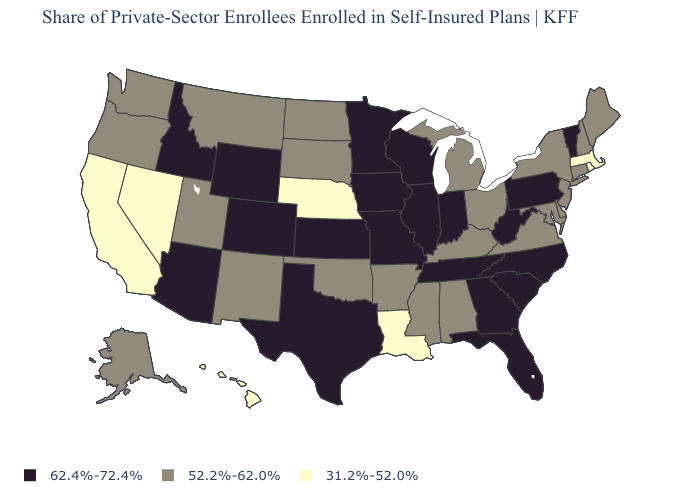What is the highest value in the USA?
Keep it brief. 62.4%-72.4%. Which states have the lowest value in the West?
Write a very short answer. California, Hawaii, Nevada. What is the highest value in states that border South Carolina?
Answer briefly. 62.4%-72.4%. What is the value of California?
Quick response, please. 31.2%-52.0%. How many symbols are there in the legend?
Quick response, please. 3. Which states have the highest value in the USA?
Concise answer only. Arizona, Colorado, Florida, Georgia, Idaho, Illinois, Indiana, Iowa, Kansas, Minnesota, Missouri, North Carolina, Pennsylvania, South Carolina, Tennessee, Texas, Vermont, West Virginia, Wisconsin, Wyoming. Which states have the highest value in the USA?
Give a very brief answer. Arizona, Colorado, Florida, Georgia, Idaho, Illinois, Indiana, Iowa, Kansas, Minnesota, Missouri, North Carolina, Pennsylvania, South Carolina, Tennessee, Texas, Vermont, West Virginia, Wisconsin, Wyoming. Does the first symbol in the legend represent the smallest category?
Be succinct. No. Does Wyoming have the highest value in the West?
Answer briefly. Yes. Which states hav the highest value in the West?
Quick response, please. Arizona, Colorado, Idaho, Wyoming. Does Nebraska have the lowest value in the USA?
Write a very short answer. Yes. Which states have the highest value in the USA?
Answer briefly. Arizona, Colorado, Florida, Georgia, Idaho, Illinois, Indiana, Iowa, Kansas, Minnesota, Missouri, North Carolina, Pennsylvania, South Carolina, Tennessee, Texas, Vermont, West Virginia, Wisconsin, Wyoming. How many symbols are there in the legend?
Keep it brief. 3. Does Texas have the same value as Wyoming?
Short answer required. Yes. What is the value of Alaska?
Keep it brief. 52.2%-62.0%. 